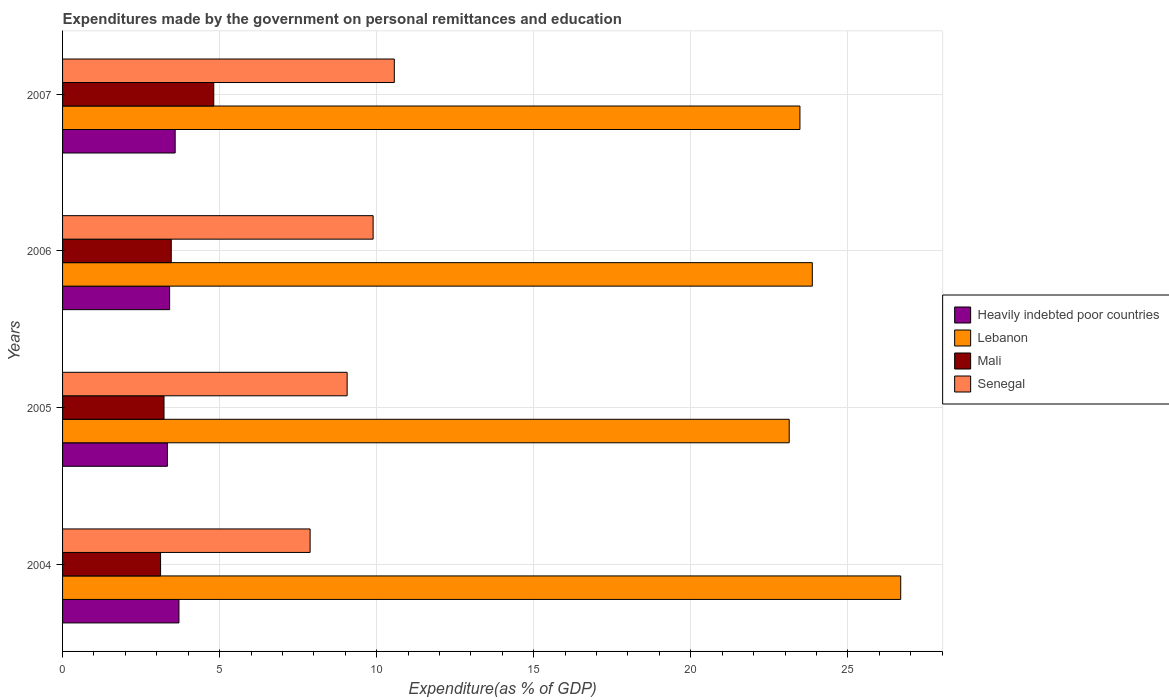How many different coloured bars are there?
Make the answer very short. 4. How many groups of bars are there?
Give a very brief answer. 4. Are the number of bars per tick equal to the number of legend labels?
Offer a very short reply. Yes. How many bars are there on the 2nd tick from the top?
Offer a very short reply. 4. How many bars are there on the 2nd tick from the bottom?
Provide a succinct answer. 4. What is the label of the 1st group of bars from the top?
Your answer should be compact. 2007. In how many cases, is the number of bars for a given year not equal to the number of legend labels?
Your response must be concise. 0. What is the expenditures made by the government on personal remittances and education in Heavily indebted poor countries in 2007?
Ensure brevity in your answer.  3.58. Across all years, what is the maximum expenditures made by the government on personal remittances and education in Lebanon?
Your response must be concise. 26.68. Across all years, what is the minimum expenditures made by the government on personal remittances and education in Heavily indebted poor countries?
Provide a short and direct response. 3.34. In which year was the expenditures made by the government on personal remittances and education in Senegal maximum?
Provide a short and direct response. 2007. In which year was the expenditures made by the government on personal remittances and education in Lebanon minimum?
Offer a terse response. 2005. What is the total expenditures made by the government on personal remittances and education in Heavily indebted poor countries in the graph?
Provide a short and direct response. 14.04. What is the difference between the expenditures made by the government on personal remittances and education in Heavily indebted poor countries in 2005 and that in 2007?
Ensure brevity in your answer.  -0.25. What is the difference between the expenditures made by the government on personal remittances and education in Heavily indebted poor countries in 2005 and the expenditures made by the government on personal remittances and education in Senegal in 2007?
Offer a very short reply. -7.22. What is the average expenditures made by the government on personal remittances and education in Mali per year?
Provide a succinct answer. 3.66. In the year 2006, what is the difference between the expenditures made by the government on personal remittances and education in Heavily indebted poor countries and expenditures made by the government on personal remittances and education in Lebanon?
Make the answer very short. -20.46. What is the ratio of the expenditures made by the government on personal remittances and education in Heavily indebted poor countries in 2005 to that in 2006?
Provide a short and direct response. 0.98. Is the difference between the expenditures made by the government on personal remittances and education in Heavily indebted poor countries in 2004 and 2006 greater than the difference between the expenditures made by the government on personal remittances and education in Lebanon in 2004 and 2006?
Make the answer very short. No. What is the difference between the highest and the second highest expenditures made by the government on personal remittances and education in Lebanon?
Keep it short and to the point. 2.82. What is the difference between the highest and the lowest expenditures made by the government on personal remittances and education in Lebanon?
Keep it short and to the point. 3.55. Is it the case that in every year, the sum of the expenditures made by the government on personal remittances and education in Lebanon and expenditures made by the government on personal remittances and education in Mali is greater than the sum of expenditures made by the government on personal remittances and education in Senegal and expenditures made by the government on personal remittances and education in Heavily indebted poor countries?
Offer a very short reply. No. What does the 1st bar from the top in 2004 represents?
Provide a succinct answer. Senegal. What does the 4th bar from the bottom in 2004 represents?
Provide a short and direct response. Senegal. How many years are there in the graph?
Make the answer very short. 4. What is the difference between two consecutive major ticks on the X-axis?
Make the answer very short. 5. Are the values on the major ticks of X-axis written in scientific E-notation?
Your answer should be compact. No. Where does the legend appear in the graph?
Provide a short and direct response. Center right. How many legend labels are there?
Give a very brief answer. 4. How are the legend labels stacked?
Offer a terse response. Vertical. What is the title of the graph?
Make the answer very short. Expenditures made by the government on personal remittances and education. What is the label or title of the X-axis?
Give a very brief answer. Expenditure(as % of GDP). What is the label or title of the Y-axis?
Keep it short and to the point. Years. What is the Expenditure(as % of GDP) in Heavily indebted poor countries in 2004?
Your answer should be very brief. 3.71. What is the Expenditure(as % of GDP) in Lebanon in 2004?
Keep it short and to the point. 26.68. What is the Expenditure(as % of GDP) in Mali in 2004?
Offer a very short reply. 3.12. What is the Expenditure(as % of GDP) in Senegal in 2004?
Keep it short and to the point. 7.88. What is the Expenditure(as % of GDP) in Heavily indebted poor countries in 2005?
Provide a succinct answer. 3.34. What is the Expenditure(as % of GDP) of Lebanon in 2005?
Offer a terse response. 23.13. What is the Expenditure(as % of GDP) of Mali in 2005?
Provide a succinct answer. 3.23. What is the Expenditure(as % of GDP) of Senegal in 2005?
Offer a very short reply. 9.06. What is the Expenditure(as % of GDP) of Heavily indebted poor countries in 2006?
Provide a succinct answer. 3.41. What is the Expenditure(as % of GDP) of Lebanon in 2006?
Your response must be concise. 23.87. What is the Expenditure(as % of GDP) of Mali in 2006?
Your response must be concise. 3.46. What is the Expenditure(as % of GDP) of Senegal in 2006?
Give a very brief answer. 9.89. What is the Expenditure(as % of GDP) in Heavily indebted poor countries in 2007?
Offer a terse response. 3.58. What is the Expenditure(as % of GDP) of Lebanon in 2007?
Your answer should be compact. 23.47. What is the Expenditure(as % of GDP) in Mali in 2007?
Make the answer very short. 4.81. What is the Expenditure(as % of GDP) in Senegal in 2007?
Offer a terse response. 10.56. Across all years, what is the maximum Expenditure(as % of GDP) of Heavily indebted poor countries?
Your response must be concise. 3.71. Across all years, what is the maximum Expenditure(as % of GDP) of Lebanon?
Your response must be concise. 26.68. Across all years, what is the maximum Expenditure(as % of GDP) of Mali?
Ensure brevity in your answer.  4.81. Across all years, what is the maximum Expenditure(as % of GDP) of Senegal?
Offer a very short reply. 10.56. Across all years, what is the minimum Expenditure(as % of GDP) of Heavily indebted poor countries?
Offer a terse response. 3.34. Across all years, what is the minimum Expenditure(as % of GDP) of Lebanon?
Your response must be concise. 23.13. Across all years, what is the minimum Expenditure(as % of GDP) of Mali?
Ensure brevity in your answer.  3.12. Across all years, what is the minimum Expenditure(as % of GDP) of Senegal?
Provide a short and direct response. 7.88. What is the total Expenditure(as % of GDP) of Heavily indebted poor countries in the graph?
Make the answer very short. 14.04. What is the total Expenditure(as % of GDP) in Lebanon in the graph?
Offer a very short reply. 97.16. What is the total Expenditure(as % of GDP) in Mali in the graph?
Ensure brevity in your answer.  14.62. What is the total Expenditure(as % of GDP) of Senegal in the graph?
Your answer should be compact. 37.39. What is the difference between the Expenditure(as % of GDP) in Heavily indebted poor countries in 2004 and that in 2005?
Offer a terse response. 0.37. What is the difference between the Expenditure(as % of GDP) in Lebanon in 2004 and that in 2005?
Your answer should be compact. 3.55. What is the difference between the Expenditure(as % of GDP) of Mali in 2004 and that in 2005?
Your answer should be very brief. -0.11. What is the difference between the Expenditure(as % of GDP) of Senegal in 2004 and that in 2005?
Offer a very short reply. -1.18. What is the difference between the Expenditure(as % of GDP) in Heavily indebted poor countries in 2004 and that in 2006?
Your answer should be very brief. 0.3. What is the difference between the Expenditure(as % of GDP) in Lebanon in 2004 and that in 2006?
Provide a succinct answer. 2.82. What is the difference between the Expenditure(as % of GDP) in Mali in 2004 and that in 2006?
Ensure brevity in your answer.  -0.34. What is the difference between the Expenditure(as % of GDP) in Senegal in 2004 and that in 2006?
Offer a terse response. -2.01. What is the difference between the Expenditure(as % of GDP) in Heavily indebted poor countries in 2004 and that in 2007?
Offer a very short reply. 0.12. What is the difference between the Expenditure(as % of GDP) of Lebanon in 2004 and that in 2007?
Give a very brief answer. 3.21. What is the difference between the Expenditure(as % of GDP) in Mali in 2004 and that in 2007?
Make the answer very short. -1.69. What is the difference between the Expenditure(as % of GDP) of Senegal in 2004 and that in 2007?
Provide a short and direct response. -2.68. What is the difference between the Expenditure(as % of GDP) of Heavily indebted poor countries in 2005 and that in 2006?
Your response must be concise. -0.07. What is the difference between the Expenditure(as % of GDP) of Lebanon in 2005 and that in 2006?
Your response must be concise. -0.74. What is the difference between the Expenditure(as % of GDP) in Mali in 2005 and that in 2006?
Offer a very short reply. -0.23. What is the difference between the Expenditure(as % of GDP) of Senegal in 2005 and that in 2006?
Make the answer very short. -0.83. What is the difference between the Expenditure(as % of GDP) in Heavily indebted poor countries in 2005 and that in 2007?
Offer a very short reply. -0.25. What is the difference between the Expenditure(as % of GDP) in Lebanon in 2005 and that in 2007?
Ensure brevity in your answer.  -0.34. What is the difference between the Expenditure(as % of GDP) in Mali in 2005 and that in 2007?
Keep it short and to the point. -1.58. What is the difference between the Expenditure(as % of GDP) of Senegal in 2005 and that in 2007?
Give a very brief answer. -1.5. What is the difference between the Expenditure(as % of GDP) of Heavily indebted poor countries in 2006 and that in 2007?
Offer a very short reply. -0.18. What is the difference between the Expenditure(as % of GDP) of Lebanon in 2006 and that in 2007?
Give a very brief answer. 0.39. What is the difference between the Expenditure(as % of GDP) of Mali in 2006 and that in 2007?
Your answer should be compact. -1.35. What is the difference between the Expenditure(as % of GDP) of Senegal in 2006 and that in 2007?
Your answer should be compact. -0.67. What is the difference between the Expenditure(as % of GDP) in Heavily indebted poor countries in 2004 and the Expenditure(as % of GDP) in Lebanon in 2005?
Ensure brevity in your answer.  -19.43. What is the difference between the Expenditure(as % of GDP) of Heavily indebted poor countries in 2004 and the Expenditure(as % of GDP) of Mali in 2005?
Your response must be concise. 0.48. What is the difference between the Expenditure(as % of GDP) of Heavily indebted poor countries in 2004 and the Expenditure(as % of GDP) of Senegal in 2005?
Give a very brief answer. -5.35. What is the difference between the Expenditure(as % of GDP) of Lebanon in 2004 and the Expenditure(as % of GDP) of Mali in 2005?
Offer a terse response. 23.45. What is the difference between the Expenditure(as % of GDP) in Lebanon in 2004 and the Expenditure(as % of GDP) in Senegal in 2005?
Ensure brevity in your answer.  17.62. What is the difference between the Expenditure(as % of GDP) in Mali in 2004 and the Expenditure(as % of GDP) in Senegal in 2005?
Offer a terse response. -5.94. What is the difference between the Expenditure(as % of GDP) of Heavily indebted poor countries in 2004 and the Expenditure(as % of GDP) of Lebanon in 2006?
Ensure brevity in your answer.  -20.16. What is the difference between the Expenditure(as % of GDP) in Heavily indebted poor countries in 2004 and the Expenditure(as % of GDP) in Mali in 2006?
Offer a terse response. 0.25. What is the difference between the Expenditure(as % of GDP) in Heavily indebted poor countries in 2004 and the Expenditure(as % of GDP) in Senegal in 2006?
Your answer should be compact. -6.18. What is the difference between the Expenditure(as % of GDP) of Lebanon in 2004 and the Expenditure(as % of GDP) of Mali in 2006?
Give a very brief answer. 23.22. What is the difference between the Expenditure(as % of GDP) in Lebanon in 2004 and the Expenditure(as % of GDP) in Senegal in 2006?
Provide a succinct answer. 16.8. What is the difference between the Expenditure(as % of GDP) of Mali in 2004 and the Expenditure(as % of GDP) of Senegal in 2006?
Provide a short and direct response. -6.77. What is the difference between the Expenditure(as % of GDP) of Heavily indebted poor countries in 2004 and the Expenditure(as % of GDP) of Lebanon in 2007?
Provide a short and direct response. -19.77. What is the difference between the Expenditure(as % of GDP) of Heavily indebted poor countries in 2004 and the Expenditure(as % of GDP) of Mali in 2007?
Provide a short and direct response. -1.11. What is the difference between the Expenditure(as % of GDP) of Heavily indebted poor countries in 2004 and the Expenditure(as % of GDP) of Senegal in 2007?
Your answer should be very brief. -6.86. What is the difference between the Expenditure(as % of GDP) of Lebanon in 2004 and the Expenditure(as % of GDP) of Mali in 2007?
Make the answer very short. 21.87. What is the difference between the Expenditure(as % of GDP) in Lebanon in 2004 and the Expenditure(as % of GDP) in Senegal in 2007?
Provide a succinct answer. 16.12. What is the difference between the Expenditure(as % of GDP) of Mali in 2004 and the Expenditure(as % of GDP) of Senegal in 2007?
Make the answer very short. -7.44. What is the difference between the Expenditure(as % of GDP) of Heavily indebted poor countries in 2005 and the Expenditure(as % of GDP) of Lebanon in 2006?
Offer a terse response. -20.53. What is the difference between the Expenditure(as % of GDP) in Heavily indebted poor countries in 2005 and the Expenditure(as % of GDP) in Mali in 2006?
Offer a terse response. -0.12. What is the difference between the Expenditure(as % of GDP) in Heavily indebted poor countries in 2005 and the Expenditure(as % of GDP) in Senegal in 2006?
Offer a terse response. -6.55. What is the difference between the Expenditure(as % of GDP) of Lebanon in 2005 and the Expenditure(as % of GDP) of Mali in 2006?
Offer a terse response. 19.67. What is the difference between the Expenditure(as % of GDP) in Lebanon in 2005 and the Expenditure(as % of GDP) in Senegal in 2006?
Your response must be concise. 13.25. What is the difference between the Expenditure(as % of GDP) of Mali in 2005 and the Expenditure(as % of GDP) of Senegal in 2006?
Keep it short and to the point. -6.66. What is the difference between the Expenditure(as % of GDP) of Heavily indebted poor countries in 2005 and the Expenditure(as % of GDP) of Lebanon in 2007?
Your answer should be very brief. -20.14. What is the difference between the Expenditure(as % of GDP) in Heavily indebted poor countries in 2005 and the Expenditure(as % of GDP) in Mali in 2007?
Offer a terse response. -1.48. What is the difference between the Expenditure(as % of GDP) in Heavily indebted poor countries in 2005 and the Expenditure(as % of GDP) in Senegal in 2007?
Your answer should be compact. -7.22. What is the difference between the Expenditure(as % of GDP) in Lebanon in 2005 and the Expenditure(as % of GDP) in Mali in 2007?
Provide a short and direct response. 18.32. What is the difference between the Expenditure(as % of GDP) of Lebanon in 2005 and the Expenditure(as % of GDP) of Senegal in 2007?
Offer a terse response. 12.57. What is the difference between the Expenditure(as % of GDP) in Mali in 2005 and the Expenditure(as % of GDP) in Senegal in 2007?
Provide a short and direct response. -7.33. What is the difference between the Expenditure(as % of GDP) in Heavily indebted poor countries in 2006 and the Expenditure(as % of GDP) in Lebanon in 2007?
Ensure brevity in your answer.  -20.07. What is the difference between the Expenditure(as % of GDP) in Heavily indebted poor countries in 2006 and the Expenditure(as % of GDP) in Mali in 2007?
Your answer should be very brief. -1.41. What is the difference between the Expenditure(as % of GDP) of Heavily indebted poor countries in 2006 and the Expenditure(as % of GDP) of Senegal in 2007?
Give a very brief answer. -7.15. What is the difference between the Expenditure(as % of GDP) in Lebanon in 2006 and the Expenditure(as % of GDP) in Mali in 2007?
Your answer should be compact. 19.05. What is the difference between the Expenditure(as % of GDP) in Lebanon in 2006 and the Expenditure(as % of GDP) in Senegal in 2007?
Keep it short and to the point. 13.31. What is the difference between the Expenditure(as % of GDP) of Mali in 2006 and the Expenditure(as % of GDP) of Senegal in 2007?
Ensure brevity in your answer.  -7.1. What is the average Expenditure(as % of GDP) in Heavily indebted poor countries per year?
Make the answer very short. 3.51. What is the average Expenditure(as % of GDP) in Lebanon per year?
Give a very brief answer. 24.29. What is the average Expenditure(as % of GDP) in Mali per year?
Make the answer very short. 3.66. What is the average Expenditure(as % of GDP) in Senegal per year?
Offer a very short reply. 9.35. In the year 2004, what is the difference between the Expenditure(as % of GDP) of Heavily indebted poor countries and Expenditure(as % of GDP) of Lebanon?
Your response must be concise. -22.98. In the year 2004, what is the difference between the Expenditure(as % of GDP) of Heavily indebted poor countries and Expenditure(as % of GDP) of Mali?
Offer a very short reply. 0.58. In the year 2004, what is the difference between the Expenditure(as % of GDP) in Heavily indebted poor countries and Expenditure(as % of GDP) in Senegal?
Keep it short and to the point. -4.18. In the year 2004, what is the difference between the Expenditure(as % of GDP) of Lebanon and Expenditure(as % of GDP) of Mali?
Offer a terse response. 23.56. In the year 2004, what is the difference between the Expenditure(as % of GDP) in Lebanon and Expenditure(as % of GDP) in Senegal?
Offer a very short reply. 18.8. In the year 2004, what is the difference between the Expenditure(as % of GDP) of Mali and Expenditure(as % of GDP) of Senegal?
Provide a short and direct response. -4.76. In the year 2005, what is the difference between the Expenditure(as % of GDP) of Heavily indebted poor countries and Expenditure(as % of GDP) of Lebanon?
Make the answer very short. -19.8. In the year 2005, what is the difference between the Expenditure(as % of GDP) in Heavily indebted poor countries and Expenditure(as % of GDP) in Mali?
Your answer should be compact. 0.11. In the year 2005, what is the difference between the Expenditure(as % of GDP) in Heavily indebted poor countries and Expenditure(as % of GDP) in Senegal?
Make the answer very short. -5.72. In the year 2005, what is the difference between the Expenditure(as % of GDP) of Lebanon and Expenditure(as % of GDP) of Mali?
Your answer should be very brief. 19.9. In the year 2005, what is the difference between the Expenditure(as % of GDP) of Lebanon and Expenditure(as % of GDP) of Senegal?
Offer a terse response. 14.07. In the year 2005, what is the difference between the Expenditure(as % of GDP) of Mali and Expenditure(as % of GDP) of Senegal?
Ensure brevity in your answer.  -5.83. In the year 2006, what is the difference between the Expenditure(as % of GDP) in Heavily indebted poor countries and Expenditure(as % of GDP) in Lebanon?
Provide a short and direct response. -20.46. In the year 2006, what is the difference between the Expenditure(as % of GDP) in Heavily indebted poor countries and Expenditure(as % of GDP) in Mali?
Your answer should be very brief. -0.05. In the year 2006, what is the difference between the Expenditure(as % of GDP) in Heavily indebted poor countries and Expenditure(as % of GDP) in Senegal?
Give a very brief answer. -6.48. In the year 2006, what is the difference between the Expenditure(as % of GDP) in Lebanon and Expenditure(as % of GDP) in Mali?
Offer a very short reply. 20.41. In the year 2006, what is the difference between the Expenditure(as % of GDP) in Lebanon and Expenditure(as % of GDP) in Senegal?
Your answer should be very brief. 13.98. In the year 2006, what is the difference between the Expenditure(as % of GDP) in Mali and Expenditure(as % of GDP) in Senegal?
Keep it short and to the point. -6.43. In the year 2007, what is the difference between the Expenditure(as % of GDP) in Heavily indebted poor countries and Expenditure(as % of GDP) in Lebanon?
Provide a succinct answer. -19.89. In the year 2007, what is the difference between the Expenditure(as % of GDP) in Heavily indebted poor countries and Expenditure(as % of GDP) in Mali?
Your answer should be compact. -1.23. In the year 2007, what is the difference between the Expenditure(as % of GDP) of Heavily indebted poor countries and Expenditure(as % of GDP) of Senegal?
Give a very brief answer. -6.98. In the year 2007, what is the difference between the Expenditure(as % of GDP) of Lebanon and Expenditure(as % of GDP) of Mali?
Offer a terse response. 18.66. In the year 2007, what is the difference between the Expenditure(as % of GDP) in Lebanon and Expenditure(as % of GDP) in Senegal?
Offer a terse response. 12.91. In the year 2007, what is the difference between the Expenditure(as % of GDP) of Mali and Expenditure(as % of GDP) of Senegal?
Your answer should be very brief. -5.75. What is the ratio of the Expenditure(as % of GDP) in Heavily indebted poor countries in 2004 to that in 2005?
Provide a short and direct response. 1.11. What is the ratio of the Expenditure(as % of GDP) in Lebanon in 2004 to that in 2005?
Ensure brevity in your answer.  1.15. What is the ratio of the Expenditure(as % of GDP) in Mali in 2004 to that in 2005?
Ensure brevity in your answer.  0.97. What is the ratio of the Expenditure(as % of GDP) of Senegal in 2004 to that in 2005?
Offer a terse response. 0.87. What is the ratio of the Expenditure(as % of GDP) in Heavily indebted poor countries in 2004 to that in 2006?
Provide a succinct answer. 1.09. What is the ratio of the Expenditure(as % of GDP) in Lebanon in 2004 to that in 2006?
Give a very brief answer. 1.12. What is the ratio of the Expenditure(as % of GDP) in Mali in 2004 to that in 2006?
Your answer should be compact. 0.9. What is the ratio of the Expenditure(as % of GDP) in Senegal in 2004 to that in 2006?
Your answer should be compact. 0.8. What is the ratio of the Expenditure(as % of GDP) in Heavily indebted poor countries in 2004 to that in 2007?
Your answer should be compact. 1.03. What is the ratio of the Expenditure(as % of GDP) of Lebanon in 2004 to that in 2007?
Keep it short and to the point. 1.14. What is the ratio of the Expenditure(as % of GDP) in Mali in 2004 to that in 2007?
Make the answer very short. 0.65. What is the ratio of the Expenditure(as % of GDP) in Senegal in 2004 to that in 2007?
Provide a succinct answer. 0.75. What is the ratio of the Expenditure(as % of GDP) of Heavily indebted poor countries in 2005 to that in 2006?
Provide a succinct answer. 0.98. What is the ratio of the Expenditure(as % of GDP) in Lebanon in 2005 to that in 2006?
Provide a short and direct response. 0.97. What is the ratio of the Expenditure(as % of GDP) in Mali in 2005 to that in 2006?
Your answer should be compact. 0.93. What is the ratio of the Expenditure(as % of GDP) in Senegal in 2005 to that in 2006?
Keep it short and to the point. 0.92. What is the ratio of the Expenditure(as % of GDP) of Lebanon in 2005 to that in 2007?
Provide a succinct answer. 0.99. What is the ratio of the Expenditure(as % of GDP) of Mali in 2005 to that in 2007?
Make the answer very short. 0.67. What is the ratio of the Expenditure(as % of GDP) of Senegal in 2005 to that in 2007?
Your response must be concise. 0.86. What is the ratio of the Expenditure(as % of GDP) of Heavily indebted poor countries in 2006 to that in 2007?
Make the answer very short. 0.95. What is the ratio of the Expenditure(as % of GDP) of Lebanon in 2006 to that in 2007?
Give a very brief answer. 1.02. What is the ratio of the Expenditure(as % of GDP) in Mali in 2006 to that in 2007?
Your answer should be very brief. 0.72. What is the ratio of the Expenditure(as % of GDP) in Senegal in 2006 to that in 2007?
Make the answer very short. 0.94. What is the difference between the highest and the second highest Expenditure(as % of GDP) of Heavily indebted poor countries?
Offer a terse response. 0.12. What is the difference between the highest and the second highest Expenditure(as % of GDP) in Lebanon?
Offer a terse response. 2.82. What is the difference between the highest and the second highest Expenditure(as % of GDP) in Mali?
Provide a succinct answer. 1.35. What is the difference between the highest and the second highest Expenditure(as % of GDP) of Senegal?
Provide a succinct answer. 0.67. What is the difference between the highest and the lowest Expenditure(as % of GDP) in Heavily indebted poor countries?
Your response must be concise. 0.37. What is the difference between the highest and the lowest Expenditure(as % of GDP) of Lebanon?
Your answer should be compact. 3.55. What is the difference between the highest and the lowest Expenditure(as % of GDP) in Mali?
Offer a very short reply. 1.69. What is the difference between the highest and the lowest Expenditure(as % of GDP) in Senegal?
Ensure brevity in your answer.  2.68. 